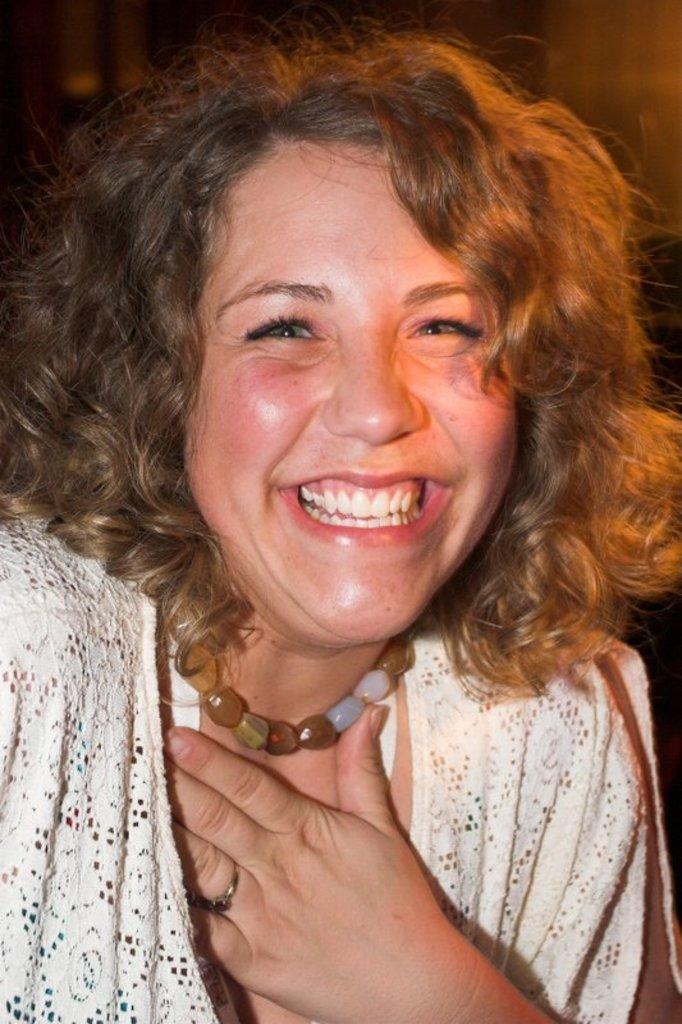Who is present in the image? There is a woman in the image. What is the woman wearing? The woman is wearing a white dress. Are there any accessories visible on the woman? Yes, the woman is wearing a necklace. What expression does the woman have on her face? There is a smile on the woman's face. How many mice are hiding in the woman's dress in the image? There are no mice present in the image, and therefore none are hiding in the woman's dress. 